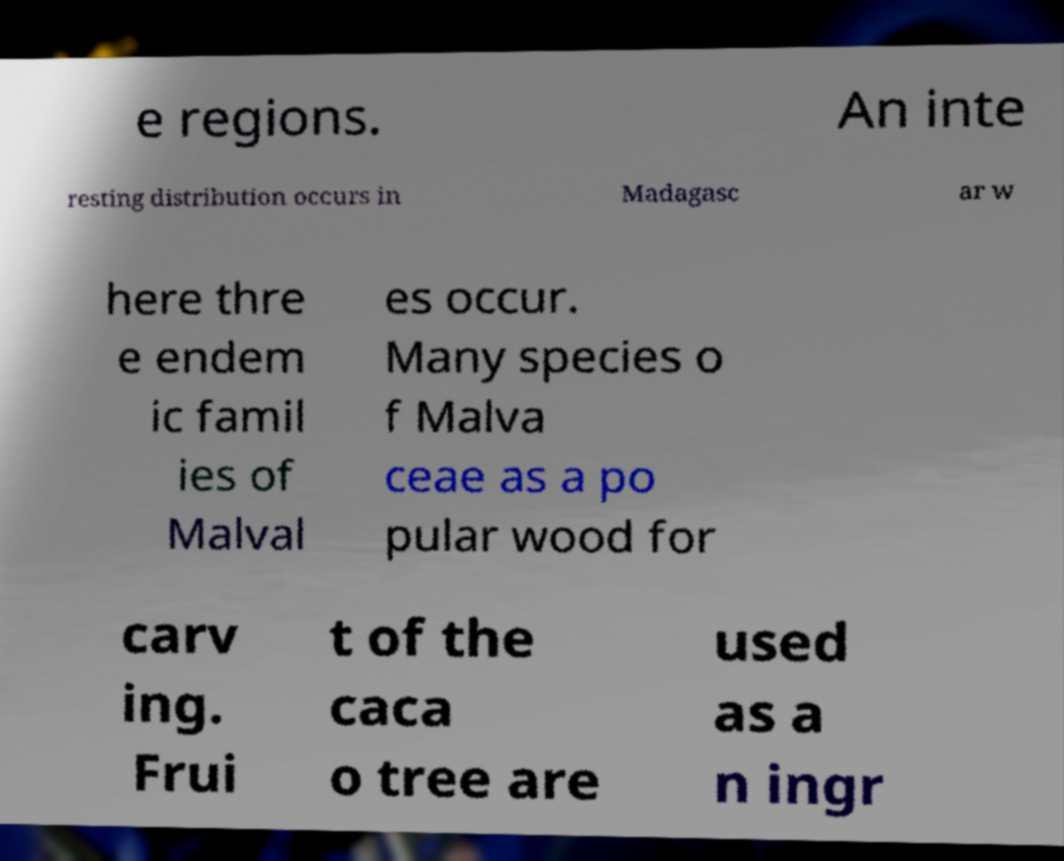There's text embedded in this image that I need extracted. Can you transcribe it verbatim? e regions. An inte resting distribution occurs in Madagasc ar w here thre e endem ic famil ies of Malval es occur. Many species o f Malva ceae as a po pular wood for carv ing. Frui t of the caca o tree are used as a n ingr 